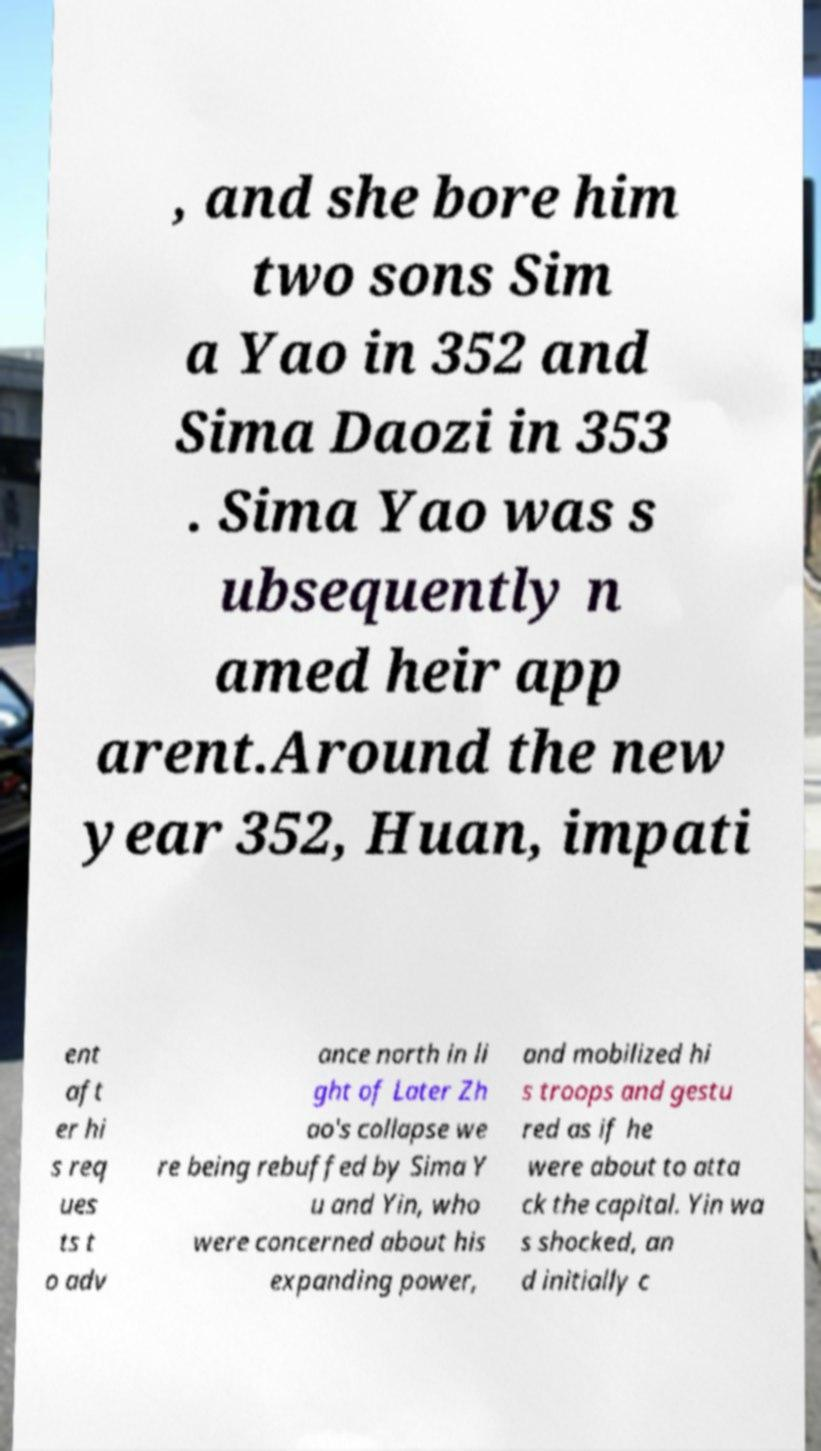What messages or text are displayed in this image? I need them in a readable, typed format. , and she bore him two sons Sim a Yao in 352 and Sima Daozi in 353 . Sima Yao was s ubsequently n amed heir app arent.Around the new year 352, Huan, impati ent aft er hi s req ues ts t o adv ance north in li ght of Later Zh ao's collapse we re being rebuffed by Sima Y u and Yin, who were concerned about his expanding power, and mobilized hi s troops and gestu red as if he were about to atta ck the capital. Yin wa s shocked, an d initially c 